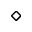<formula> <loc_0><loc_0><loc_500><loc_500>\diamond</formula> 